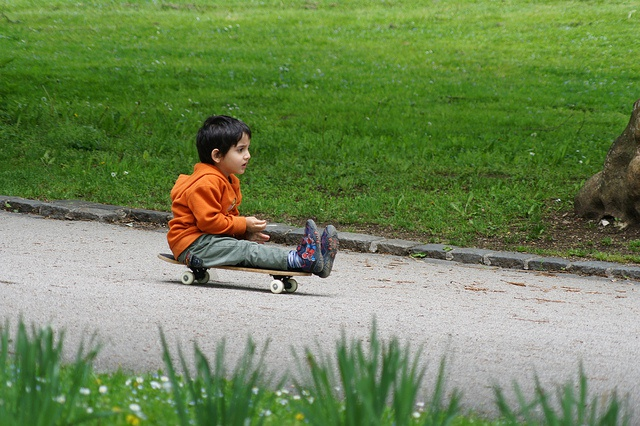Describe the objects in this image and their specific colors. I can see people in olive, black, gray, red, and maroon tones and skateboard in olive, black, lightgray, darkgray, and gray tones in this image. 